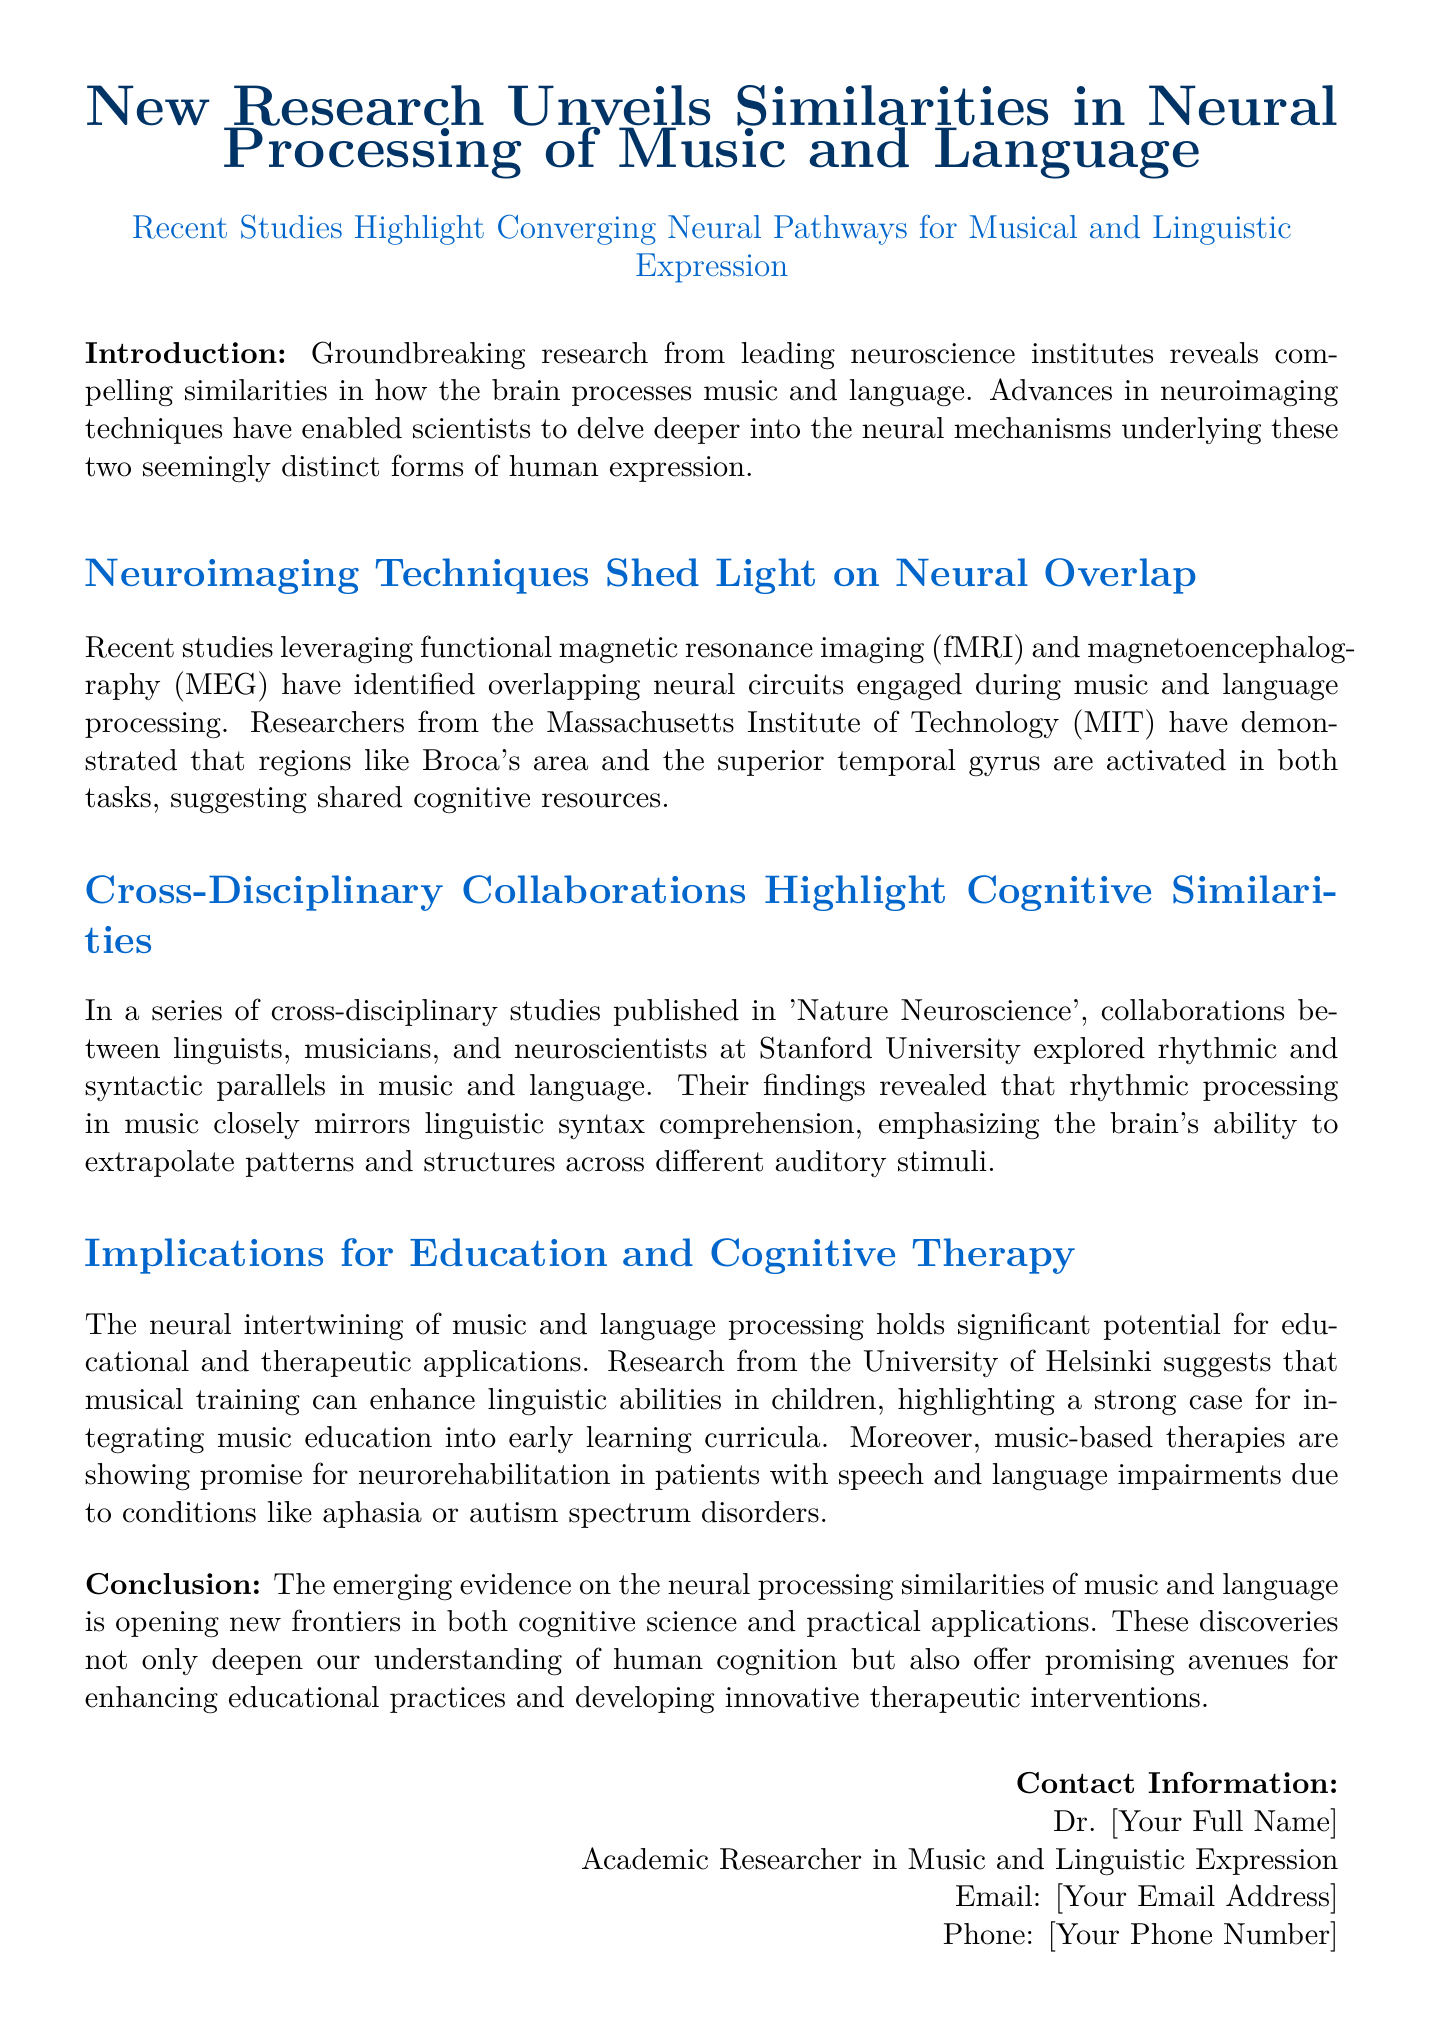What are the two forms of human expression discussed? The document mentions music and language as the two forms of human expression being studied in terms of their neural processing.
Answer: music and language Which neuroimaging techniques are highlighted in the studies? The studies mentioned in the document utilize functional magnetic resonance imaging (fMRI) and magnetoencephalography (MEG) to examine brain activity.
Answer: fMRI and MEG Which brain regions are activated during both music and language tasks? The document specifies that Broca's area and the superior temporal gyrus are the brain regions identified as activated during both tasks.
Answer: Broca's area and the superior temporal gyrus What is the publication where the cross-disciplinary studies are reported? The document refers to 'Nature Neuroscience' as the journal where the collaborative studies were published.
Answer: Nature Neuroscience What potential educational benefit is suggested from musical training? According to the University of Helsinki research mentioned in the document, musical training can enhance linguistic abilities in children, indicating a significant educational benefit.
Answer: enhance linguistic abilities What therapeutic application is mentioned related to music processing? The document suggests that music-based therapies are promising for neurorehabilitation in patients with speech and language impairments like aphasia or autism spectrum disorders.
Answer: neurorehabilitation Who conducted the research mentioned in the press release? The document states that leading neuroscience institutes were involved in the research, notably mentioning MIT and Stanford University.
Answer: MIT and Stanford University In what year does this research emerge? The press release does not specify a precise year, but it implies it refers to recent studies without giving a specific date; it leads to the assumption it's contemporary.
Answer: recent studies 